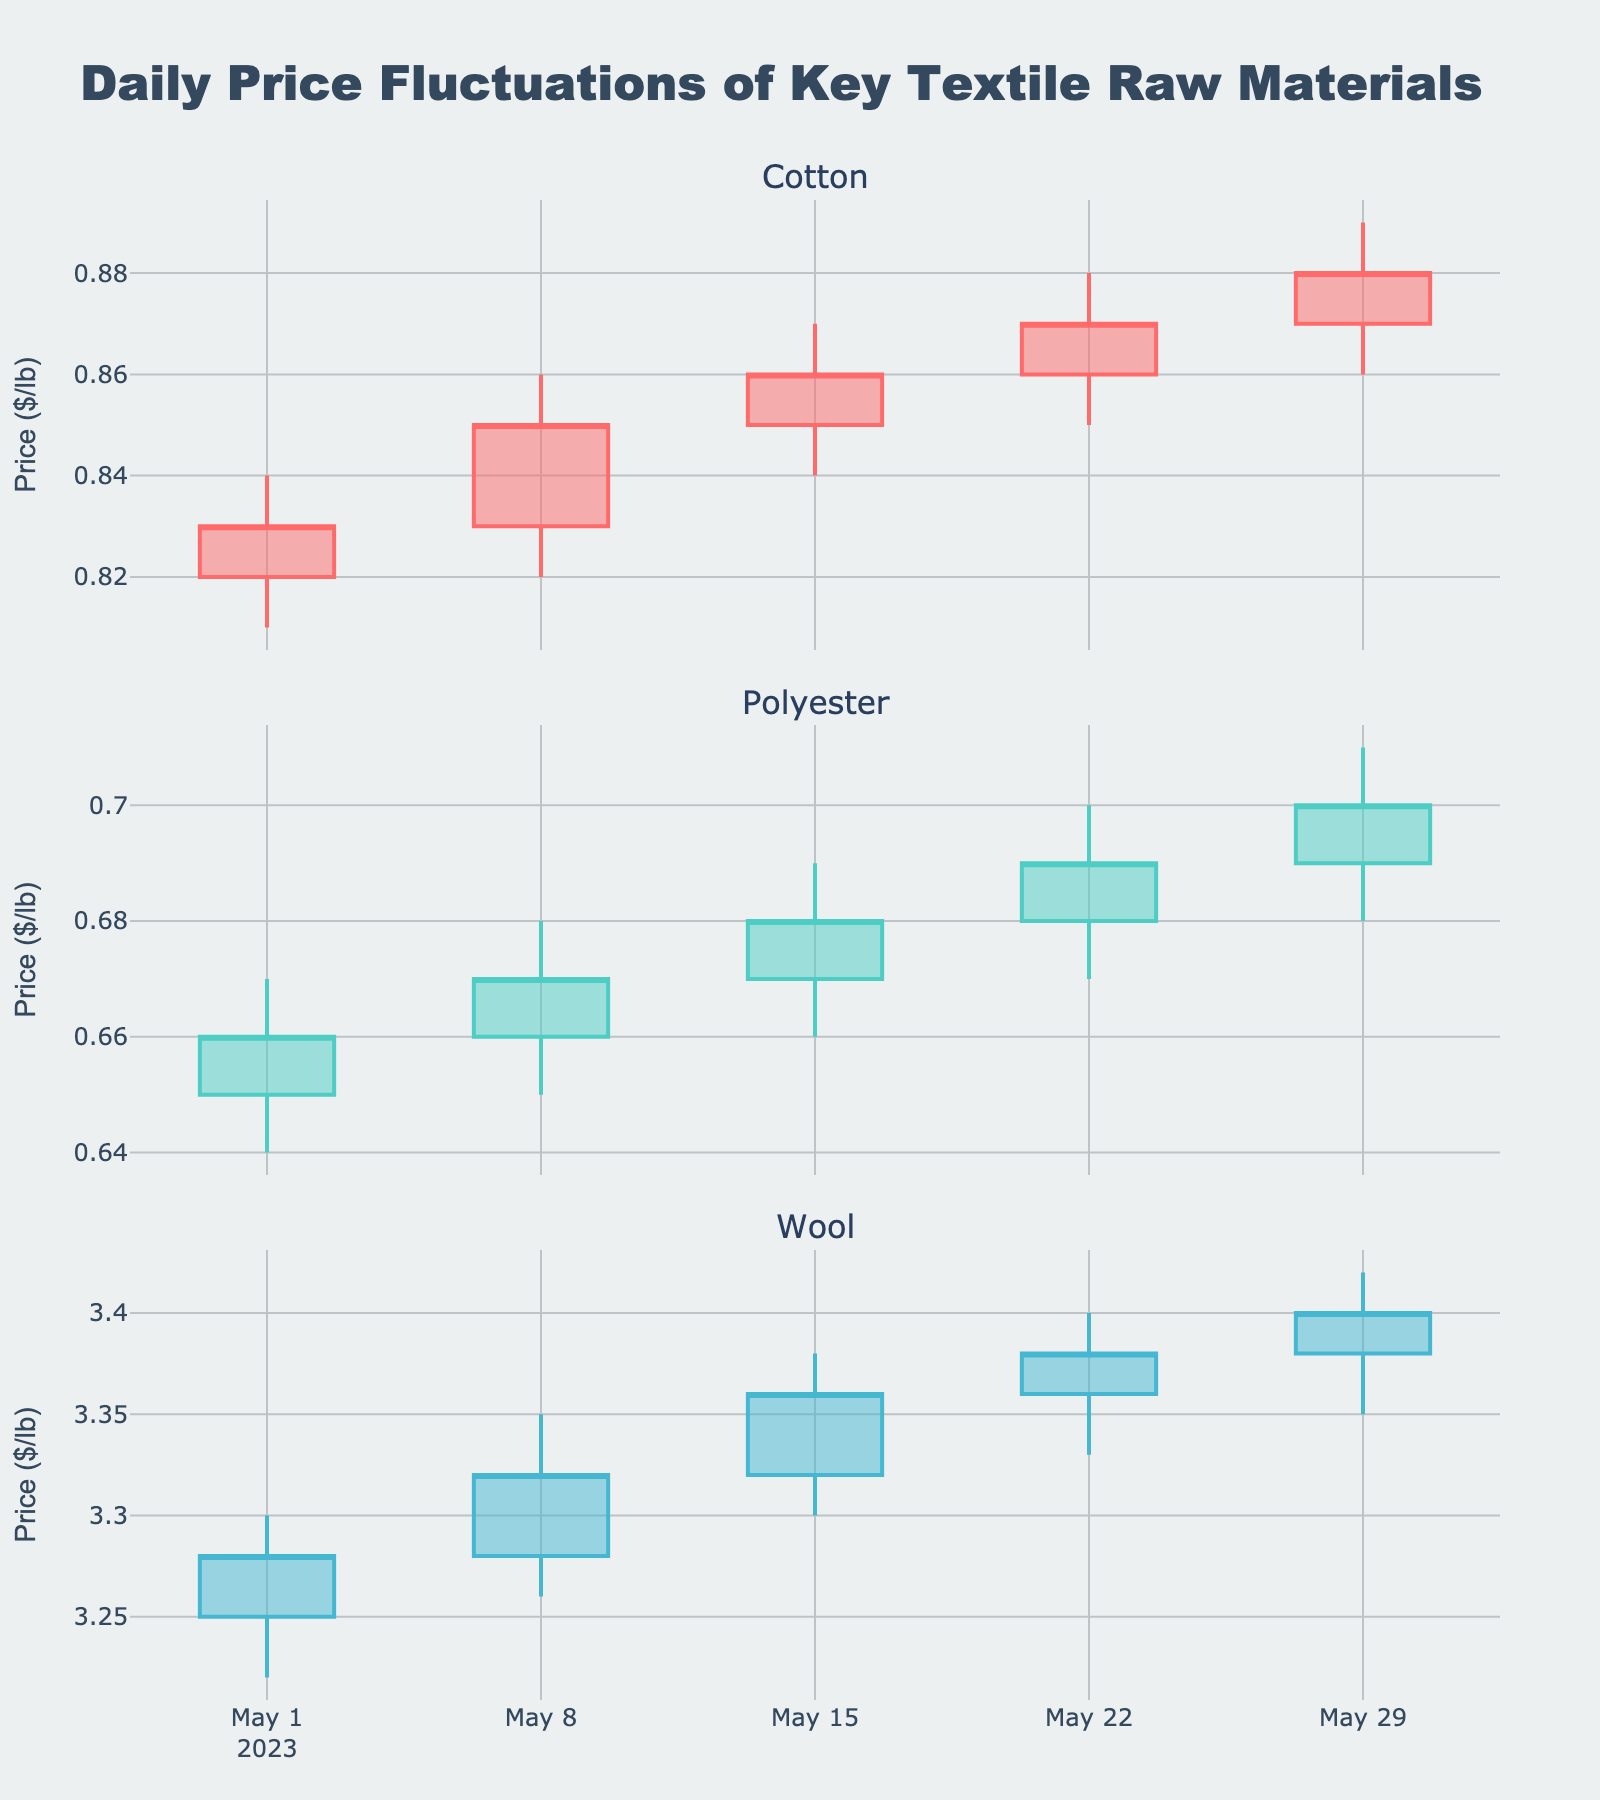What is the title of the figure? The title is usually displayed at the top of the figure. In this case, it is 'Daily Price Fluctuations of Key Textile Raw Materials.'
Answer: Daily Price Fluctuations of Key Textile Raw Materials Which material experienced the highest peak price throughout the month? Observe the highest value on the High axis for each material. Wool reached 3.42 on May 29, which is higher than the peaks of Cotton and Polyester.
Answer: Wool What was the closing price of Polyester on May 22? Locate the May 22 candlestick for Polyester and note the closing price, which is the top edge of the body if it's an increasing candle, or the bottom edge if it's decreasing. The closing price is 0.69.
Answer: 0.69 On which date did Cotton have the smallest price range? Calculate the price range for Cotton on each date (High - Low) and find the smallest. Cotton had price ranges of 0.03, 0.04, 0.03, 0.03, and 0.03. The smallest range is on May 1 with a range of 0.03.
Answer: May 1 How did Wool's closing price trend over the month? Observe the closing prices of Wool at each date: 3.28, 3.32, 3.36, 3.38, 3.40. The trend is a steady increase throughout the month.
Answer: Increasing Which material had the smallest change in closing price from May 1 to May 29? Calculate the change in closing price for each material from May 1 to May 29. Cotton changes from 0.83 to 0.88 (0.05), Polyester from 0.66 to 0.70 (0.04), and Wool from 3.28 to 3.40 (0.12). Polyester has the smallest change.
Answer: Polyester Is there any day where all three materials had increasing closing prices? Check if all three materials have a higher closing price than the previous day's closing on the same date. On May 8 and May 15, all three materials had higher closing prices compared to the previous data points.
Answer: Yes, May 8 and May 15 How many times did Cotton's closing price increase over the month? Compare the closing prices of Cotton on consecutive dates and count the number of increases: 0.83 to 0.85, 0.85 to 0.86, 0.86 to 0.87, 0.87 to 0.88. All four changes are increases.
Answer: 4 times 